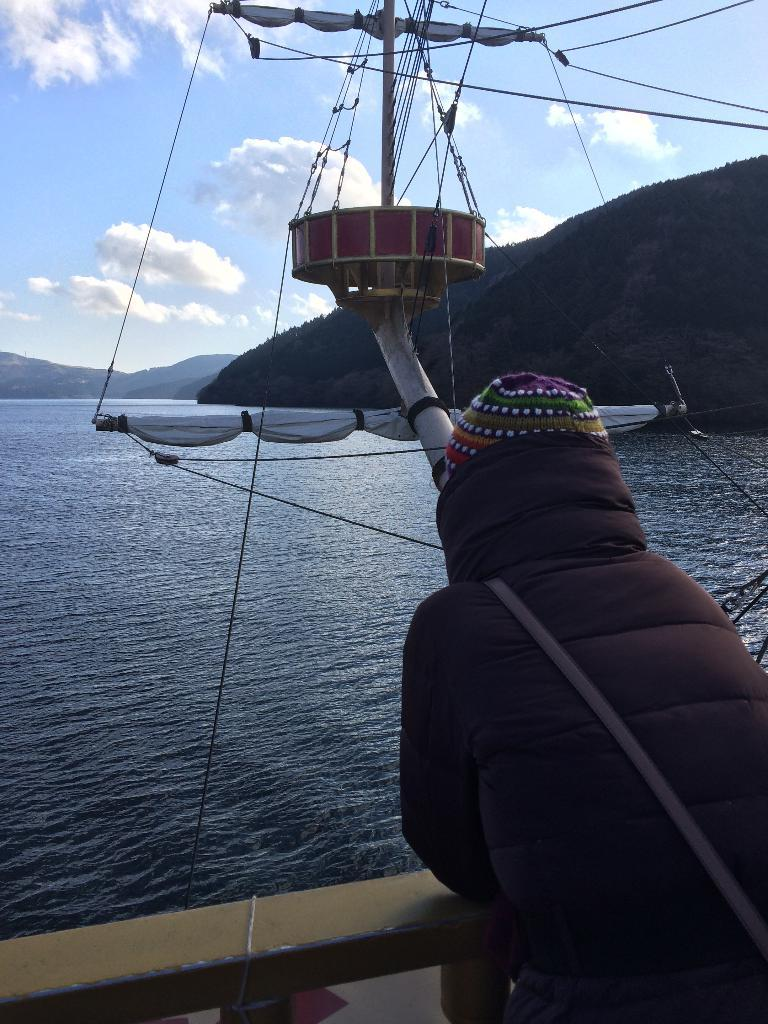What is the person in the image wearing? The person is wearing a sweater and cap in the image. Where is the person located in the image? The person is standing in a boat. What is the boat doing in the image? The boat is floating in the water. What can be seen in the background of the image? There are hills and the sky visible in the background of the image. What is the condition of the sky in the image? The sky is visible in the background of the image, and clouds are present. How many beds can be seen in the image? There are no beds present in the image. What type of harmony is being played by the person in the image? There is no indication of music or harmony in the image; the person is simply standing in a boat. 